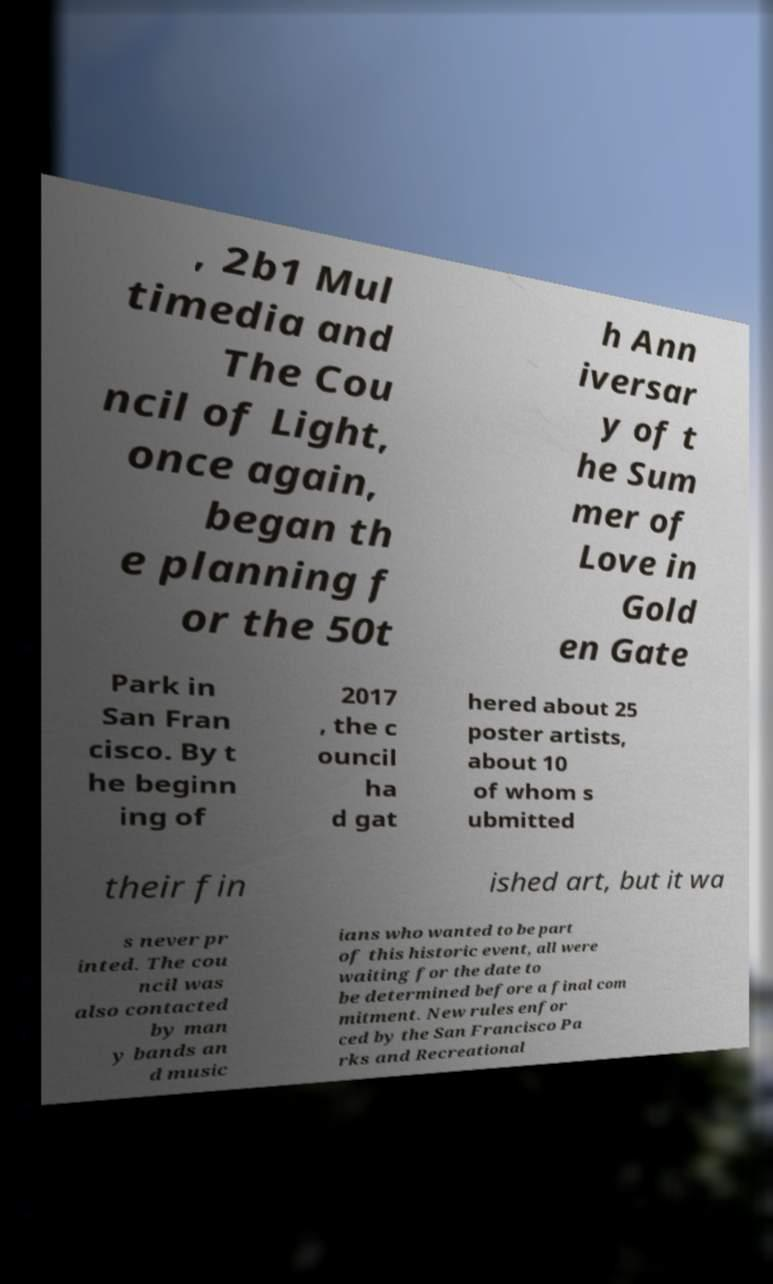Can you read and provide the text displayed in the image?This photo seems to have some interesting text. Can you extract and type it out for me? , 2b1 Mul timedia and The Cou ncil of Light, once again, began th e planning f or the 50t h Ann iversar y of t he Sum mer of Love in Gold en Gate Park in San Fran cisco. By t he beginn ing of 2017 , the c ouncil ha d gat hered about 25 poster artists, about 10 of whom s ubmitted their fin ished art, but it wa s never pr inted. The cou ncil was also contacted by man y bands an d music ians who wanted to be part of this historic event, all were waiting for the date to be determined before a final com mitment. New rules enfor ced by the San Francisco Pa rks and Recreational 